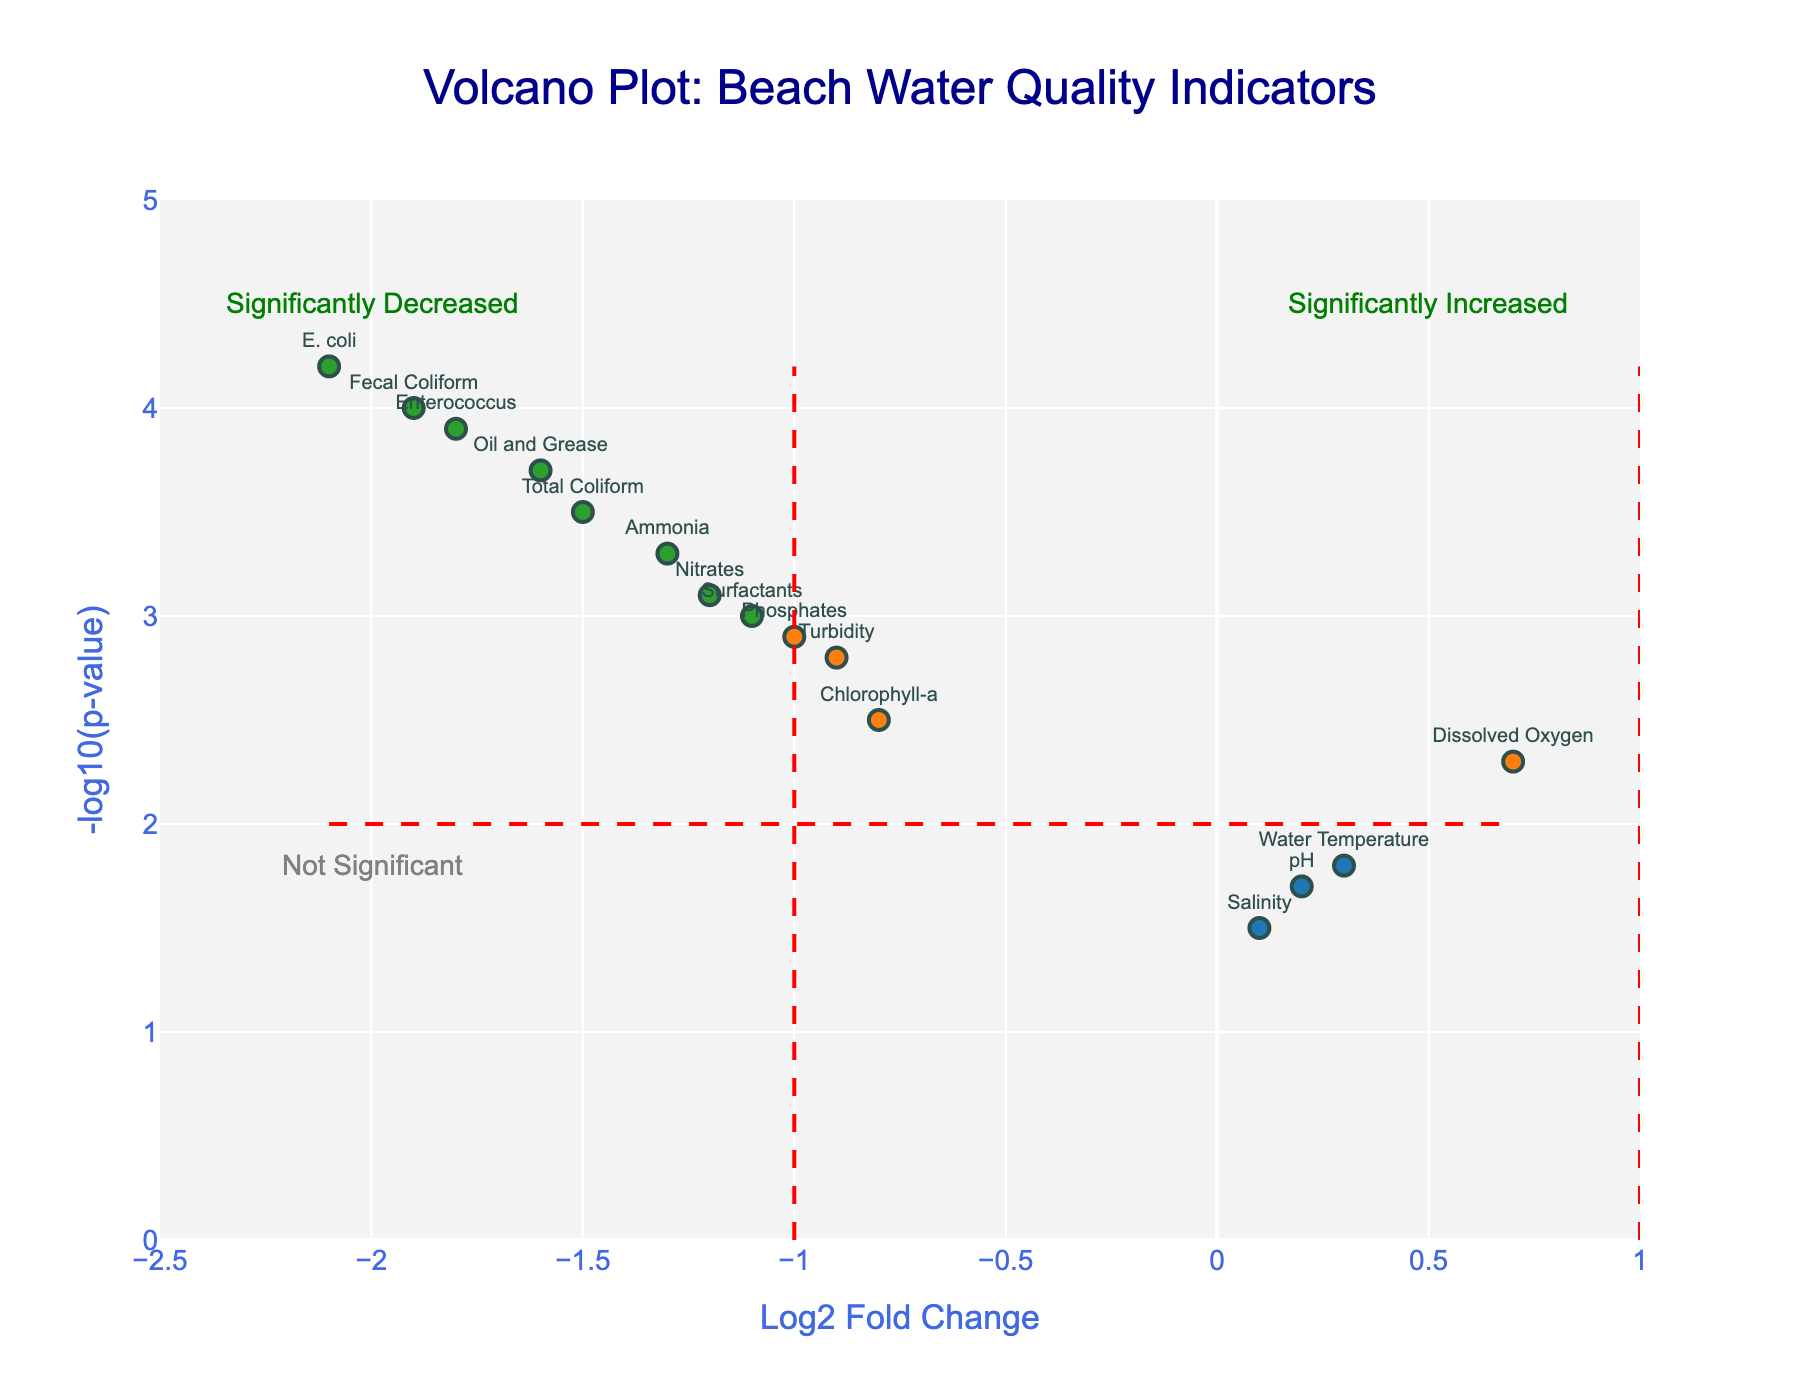How many indicators in the plot have significantly decreased? Significantly decreased indicators are those with Log2FoldChange less than -1 and NegativeLog10PValue greater than 2. We count the points that satisfy these conditions: E. coli, Enterococcus, Total Coliform, Nitrates, Oil and Grease, Ammonia, Fecal Coliform.
Answer: 7 Which indicator has the highest -log10(p-value)? To find the highest -log10(p-value), look at the y-axis and find the point that reaches the highest value. E. coli has the highest value at 4.2.
Answer: E. coli What is the log2 fold change of Total Coliform? Locate Total Coliform on the plot and read its corresponding value on the x-axis. Total Coliform's Log2FoldChange is -1.5.
Answer: -1.5 Which indicators lie in the "Not Significant" region? The "Not Significant" region is below the -log10(p-value) of 2 regardless of the Log2FoldChange. The indicators are pH, Salinity, and Water Temperature.
Answer: pH, Salinity, Water Temperature Compare the Log2FoldChange of E. coli and Enterococcus. Which is lower? Find the points for E. coli and Enterococcus on the x-axis. E. coli has a Log2FoldChange of -2.1, and Enterococcus has -1.8. Therefore, E. coli's Log2FoldChange is lower.
Answer: E. coli What is the approximate range of the -log10(p-value) values displayed on the plot? Identify the minimum and maximum y-axis values among the points. The minimum is approximately 1.5, and the maximum is approximately 4.2.
Answer: 1.5 to 4.2 Which indicators have Log2FoldChange values greater than 0? Indicators with Log2FoldChange values greater than 0 are pH, Dissolved Oxygen, Salinity, and Water Temperature.
Answer: pH, Dissolved Oxygen, Salinity, Water Temperature What does the vertical red dashed line at Log2FoldChange = -1 signify? The vertical red dashed line at Log2FoldChange = -1 indicates the threshold for a significant decrease in quality indicators.
Answer: Threshold for significant decrease How many data points fall outside the horizontal threshold line for signifiant p-values? Data points outside the horizontal red dashed line (i.e., above -log10(p-value) = 2) indicate significant p-values. Count these points: E. coli, Enterococcus, Total Coliform, Oil and Grease, Fecal Coliform, Nitrates, Ammonia, Surfactants, Phosphates, Turbidity, Chlorophyll-a.
Answer: 11 